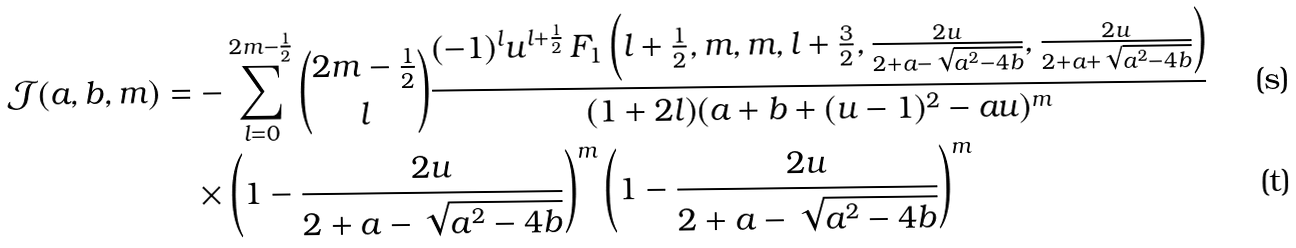Convert formula to latex. <formula><loc_0><loc_0><loc_500><loc_500>\mathcal { J } ( a , b , m ) & = - \sum _ { l = 0 } ^ { 2 m - \frac { 1 } { 2 } } \binom { 2 m - \frac { 1 } { 2 } } { l } \frac { ( - 1 ) ^ { l } u ^ { l + \frac { 1 } { 2 } } \, F _ { 1 } \left ( l + \frac { 1 } { 2 } , m , m , l + \frac { 3 } { 2 } , \frac { 2 u } { 2 + a - \sqrt { a ^ { 2 } - 4 b } } , \frac { 2 u } { 2 + a + \sqrt { a ^ { 2 } - 4 b } } \right ) } { ( 1 + 2 l ) ( a + b + ( u - 1 ) ^ { 2 } - a u ) ^ { m } } \\ & \quad \times \left ( 1 - \frac { 2 u } { 2 + a - \sqrt { a ^ { 2 } - 4 b } } \right ) ^ { m } \left ( 1 - \frac { 2 u } { 2 + a - \sqrt { a ^ { 2 } - 4 b } } \right ) ^ { m }</formula> 